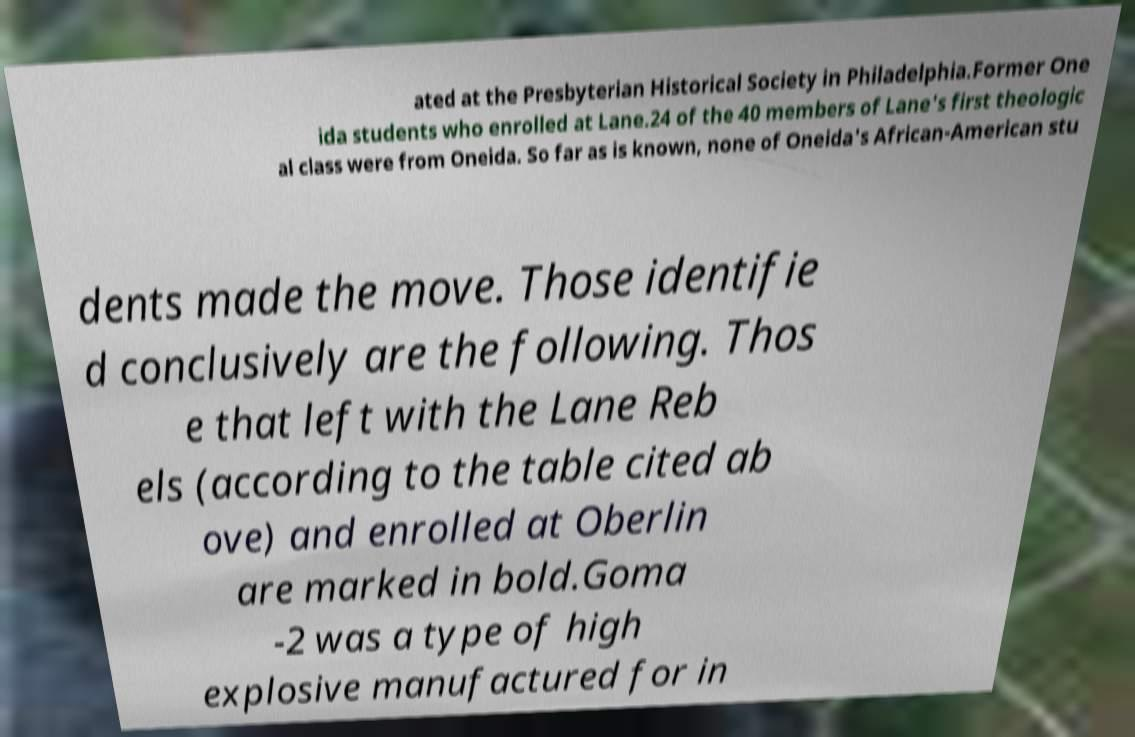For documentation purposes, I need the text within this image transcribed. Could you provide that? ated at the Presbyterian Historical Society in Philadelphia.Former One ida students who enrolled at Lane.24 of the 40 members of Lane's first theologic al class were from Oneida. So far as is known, none of Oneida's African-American stu dents made the move. Those identifie d conclusively are the following. Thos e that left with the Lane Reb els (according to the table cited ab ove) and enrolled at Oberlin are marked in bold.Goma -2 was a type of high explosive manufactured for in 